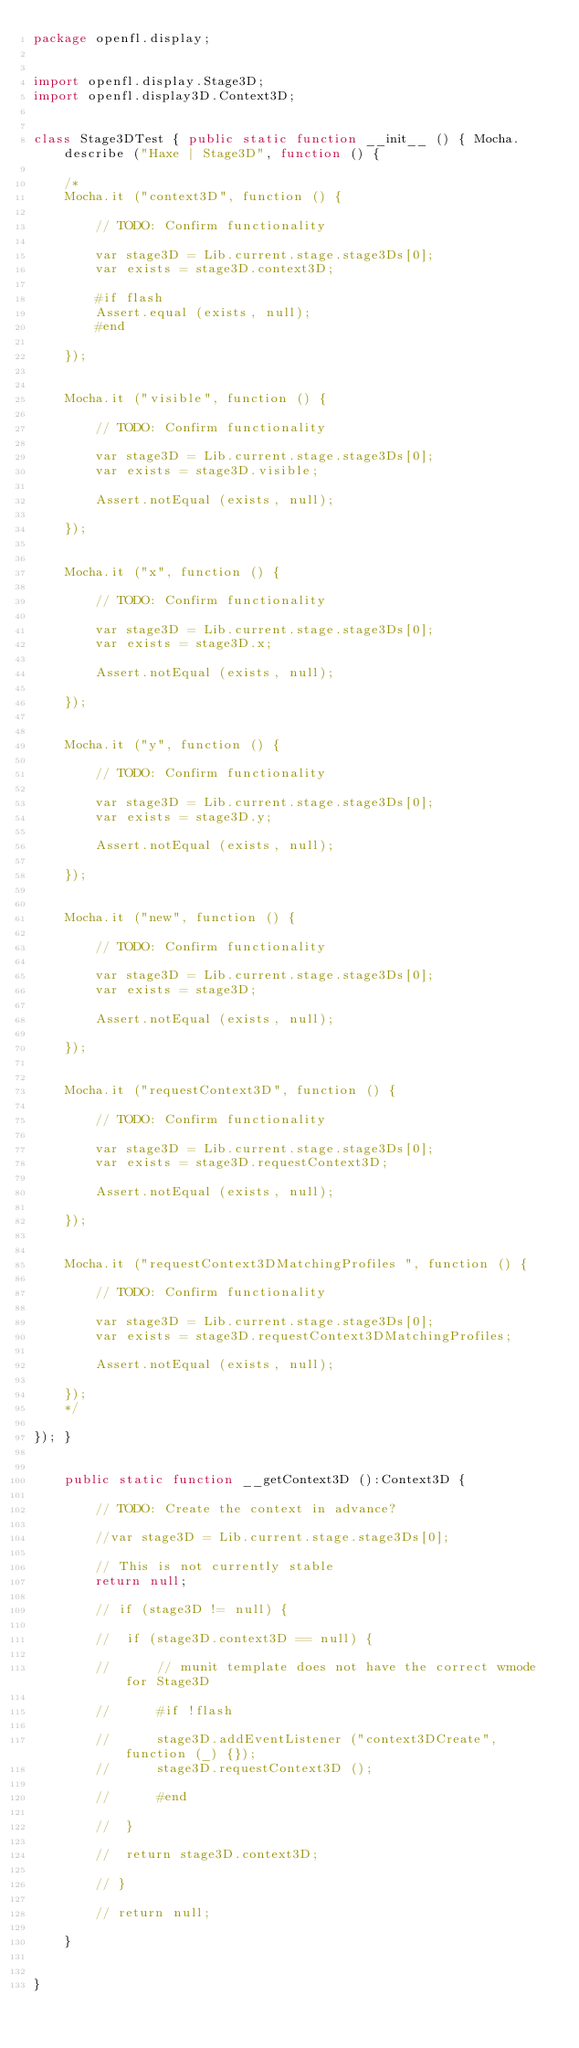<code> <loc_0><loc_0><loc_500><loc_500><_Haxe_>package openfl.display;


import openfl.display.Stage3D;
import openfl.display3D.Context3D;


class Stage3DTest { public static function __init__ () { Mocha.describe ("Haxe | Stage3D", function () {
	
	/*
	Mocha.it ("context3D", function () {
		
		// TODO: Confirm functionality
		
		var stage3D = Lib.current.stage.stage3Ds[0];
		var exists = stage3D.context3D;
		
		#if flash
		Assert.equal (exists, null);
		#end
		
	});
	
	
	Mocha.it ("visible", function () {
		
		// TODO: Confirm functionality
		
		var stage3D = Lib.current.stage.stage3Ds[0];
		var exists = stage3D.visible;
		
		Assert.notEqual (exists, null);
		
	});
	
	
	Mocha.it ("x", function () {
		
		// TODO: Confirm functionality
		
		var stage3D = Lib.current.stage.stage3Ds[0];
		var exists = stage3D.x;
		
		Assert.notEqual (exists, null);
		
	});
	
	
	Mocha.it ("y", function () {
		
		// TODO: Confirm functionality
		
		var stage3D = Lib.current.stage.stage3Ds[0];
		var exists = stage3D.y;
		
		Assert.notEqual (exists, null);
		
	});
	
	
	Mocha.it ("new", function () {
		
		// TODO: Confirm functionality
		
		var stage3D = Lib.current.stage.stage3Ds[0];
		var exists = stage3D;
		
		Assert.notEqual (exists, null);
		
	});
	
	
	Mocha.it ("requestContext3D", function () {
		
		// TODO: Confirm functionality
		
		var stage3D = Lib.current.stage.stage3Ds[0];
		var exists = stage3D.requestContext3D;
		
		Assert.notEqual (exists, null);
		
	});
	
	
	Mocha.it ("requestContext3DMatchingProfiles ", function () {
		
		// TODO: Confirm functionality
		
		var stage3D = Lib.current.stage.stage3Ds[0];
		var exists = stage3D.requestContext3DMatchingProfiles;
		
		Assert.notEqual (exists, null);
		
	});
	*/
	
}); }
	
	
	public static function __getContext3D ():Context3D {
		
		// TODO: Create the context in advance?
		
		//var stage3D = Lib.current.stage.stage3Ds[0];
		
		// This is not currently stable
		return null;
		
		// if (stage3D != null) {
			
		// 	if (stage3D.context3D == null) {
				
		// 		// munit template does not have the correct wmode for Stage3D
				
		// 		#if !flash
				
		// 		stage3D.addEventListener ("context3DCreate", function (_) {});
		// 		stage3D.requestContext3D ();
				
		// 		#end
				
		// 	}
			
		// 	return stage3D.context3D;
			
		// }
		
		// return null;
		
	}
	
	
}</code> 